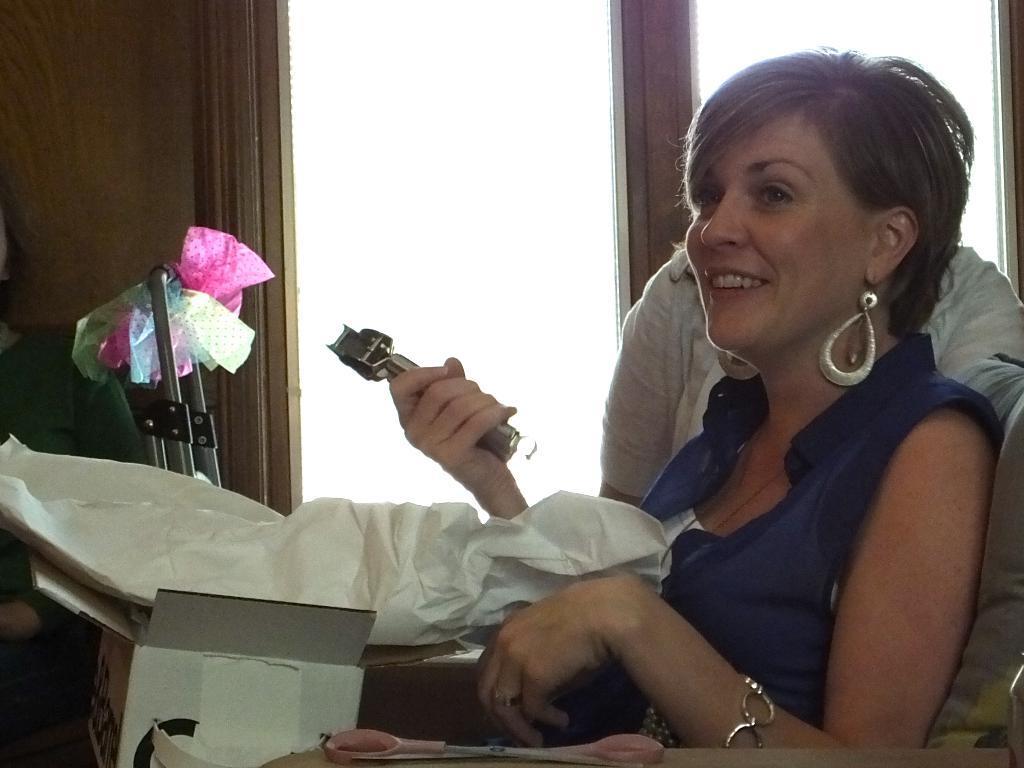How would you summarize this image in a sentence or two? In the image we can see the woman on the right side of the image. She is sitting, wearing clothes, the bracelet, earrings and she is smiling and she is holding an object in her hand. Here we can see the carton box and other objects. Here we can see the window. 